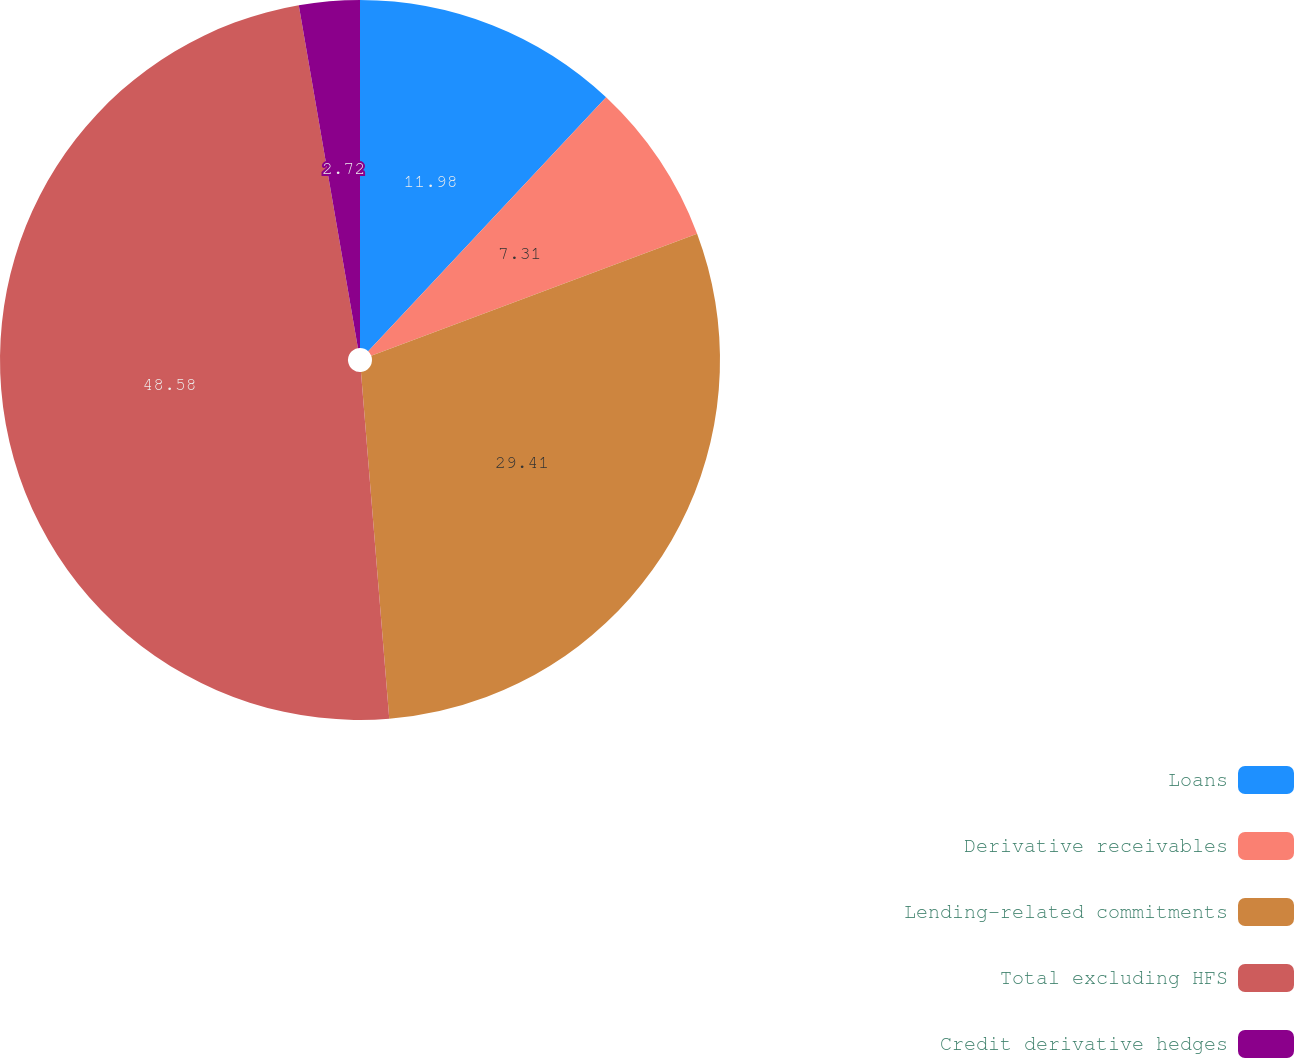Convert chart. <chart><loc_0><loc_0><loc_500><loc_500><pie_chart><fcel>Loans<fcel>Derivative receivables<fcel>Lending-related commitments<fcel>Total excluding HFS<fcel>Credit derivative hedges<nl><fcel>11.98%<fcel>7.31%<fcel>29.41%<fcel>48.57%<fcel>2.72%<nl></chart> 